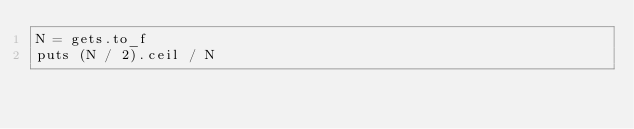Convert code to text. <code><loc_0><loc_0><loc_500><loc_500><_Ruby_>N = gets.to_f
puts (N / 2).ceil / N</code> 